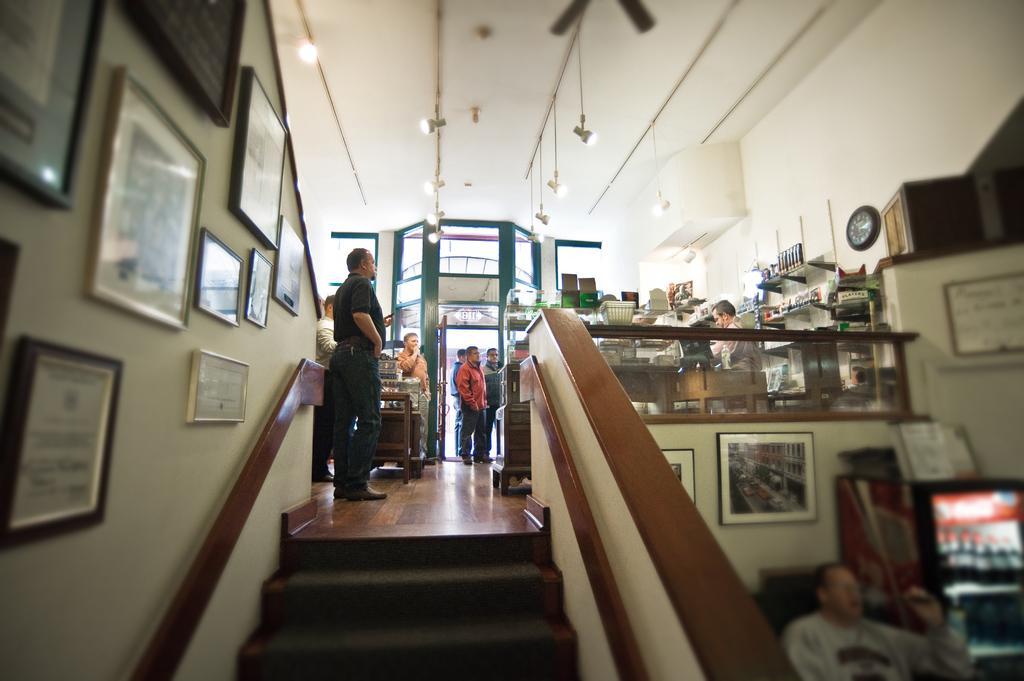How would you summarize this image in a sentence or two? As we can see in the image there is a wall, photo frame,s few people here and there, stairs, lights and a fan. 